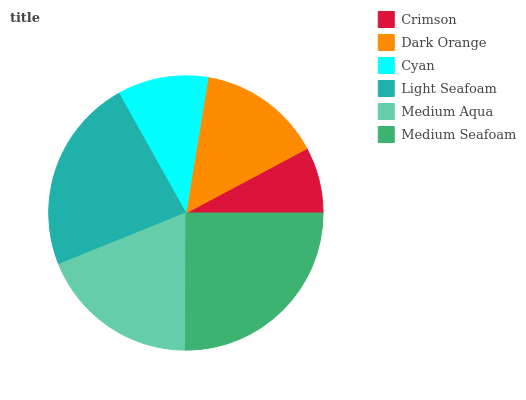Is Crimson the minimum?
Answer yes or no. Yes. Is Medium Seafoam the maximum?
Answer yes or no. Yes. Is Dark Orange the minimum?
Answer yes or no. No. Is Dark Orange the maximum?
Answer yes or no. No. Is Dark Orange greater than Crimson?
Answer yes or no. Yes. Is Crimson less than Dark Orange?
Answer yes or no. Yes. Is Crimson greater than Dark Orange?
Answer yes or no. No. Is Dark Orange less than Crimson?
Answer yes or no. No. Is Medium Aqua the high median?
Answer yes or no. Yes. Is Dark Orange the low median?
Answer yes or no. Yes. Is Cyan the high median?
Answer yes or no. No. Is Light Seafoam the low median?
Answer yes or no. No. 